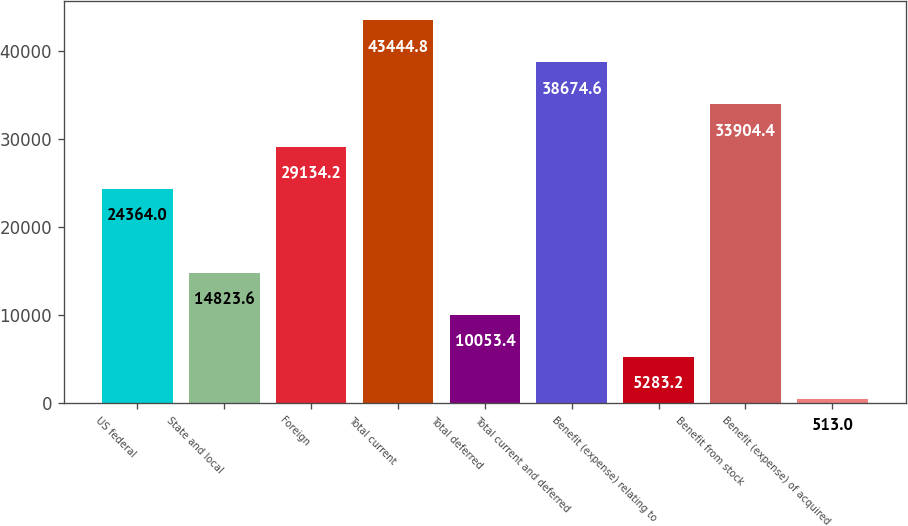<chart> <loc_0><loc_0><loc_500><loc_500><bar_chart><fcel>US federal<fcel>State and local<fcel>Foreign<fcel>Total current<fcel>Total deferred<fcel>Total current and deferred<fcel>Benefit (expense) relating to<fcel>Benefit from stock<fcel>Benefit (expense) of acquired<nl><fcel>24364<fcel>14823.6<fcel>29134.2<fcel>43444.8<fcel>10053.4<fcel>38674.6<fcel>5283.2<fcel>33904.4<fcel>513<nl></chart> 